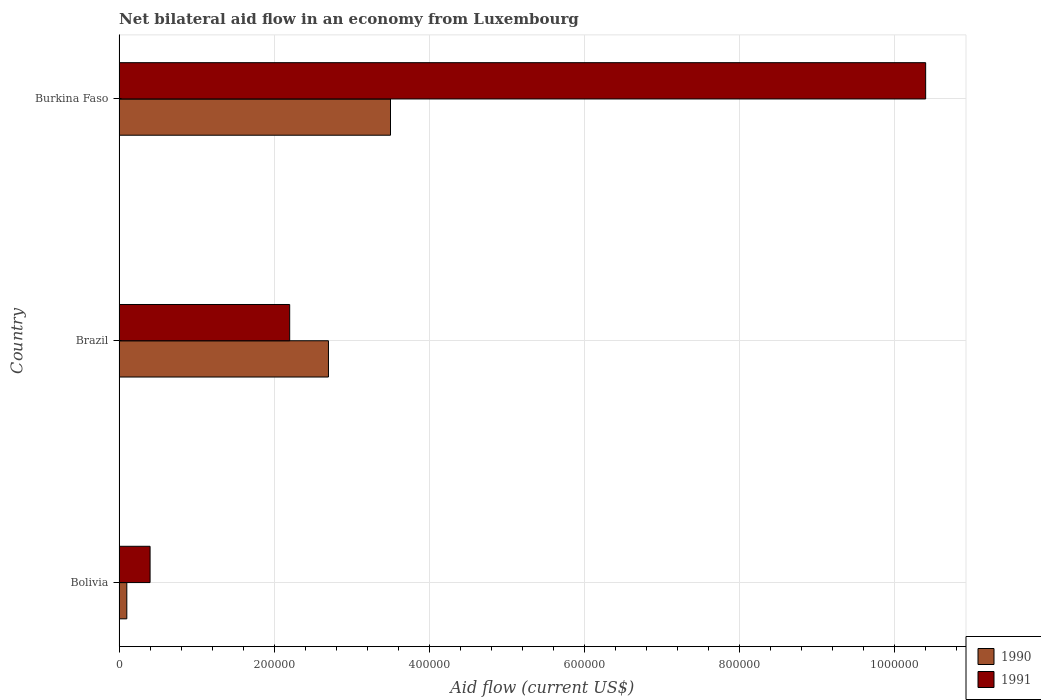How many groups of bars are there?
Offer a very short reply. 3. Are the number of bars on each tick of the Y-axis equal?
Give a very brief answer. Yes. How many bars are there on the 1st tick from the bottom?
Offer a very short reply. 2. What is the label of the 1st group of bars from the top?
Provide a short and direct response. Burkina Faso. In how many cases, is the number of bars for a given country not equal to the number of legend labels?
Your answer should be very brief. 0. Across all countries, what is the maximum net bilateral aid flow in 1991?
Keep it short and to the point. 1.04e+06. In which country was the net bilateral aid flow in 1991 maximum?
Give a very brief answer. Burkina Faso. In which country was the net bilateral aid flow in 1991 minimum?
Keep it short and to the point. Bolivia. What is the total net bilateral aid flow in 1990 in the graph?
Your answer should be very brief. 6.30e+05. What is the difference between the net bilateral aid flow in 1991 in Brazil and that in Burkina Faso?
Offer a very short reply. -8.20e+05. What is the difference between the net bilateral aid flow in 1991 in Burkina Faso and the net bilateral aid flow in 1990 in Bolivia?
Your answer should be compact. 1.03e+06. What is the average net bilateral aid flow in 1990 per country?
Ensure brevity in your answer.  2.10e+05. What is the difference between the net bilateral aid flow in 1991 and net bilateral aid flow in 1990 in Burkina Faso?
Ensure brevity in your answer.  6.90e+05. In how many countries, is the net bilateral aid flow in 1990 greater than 520000 US$?
Keep it short and to the point. 0. What is the ratio of the net bilateral aid flow in 1990 in Bolivia to that in Brazil?
Offer a terse response. 0.04. What is the difference between the highest and the second highest net bilateral aid flow in 1990?
Make the answer very short. 8.00e+04. What is the difference between the highest and the lowest net bilateral aid flow in 1991?
Provide a short and direct response. 1.00e+06. In how many countries, is the net bilateral aid flow in 1990 greater than the average net bilateral aid flow in 1990 taken over all countries?
Offer a very short reply. 2. Is the sum of the net bilateral aid flow in 1991 in Bolivia and Burkina Faso greater than the maximum net bilateral aid flow in 1990 across all countries?
Provide a succinct answer. Yes. What does the 2nd bar from the top in Bolivia represents?
Give a very brief answer. 1990. What does the 2nd bar from the bottom in Burkina Faso represents?
Provide a short and direct response. 1991. Does the graph contain grids?
Provide a succinct answer. Yes. Where does the legend appear in the graph?
Keep it short and to the point. Bottom right. How many legend labels are there?
Give a very brief answer. 2. What is the title of the graph?
Give a very brief answer. Net bilateral aid flow in an economy from Luxembourg. Does "1972" appear as one of the legend labels in the graph?
Offer a very short reply. No. What is the label or title of the X-axis?
Keep it short and to the point. Aid flow (current US$). What is the label or title of the Y-axis?
Your answer should be compact. Country. What is the Aid flow (current US$) of 1990 in Brazil?
Offer a terse response. 2.70e+05. What is the Aid flow (current US$) in 1991 in Burkina Faso?
Make the answer very short. 1.04e+06. Across all countries, what is the maximum Aid flow (current US$) of 1990?
Give a very brief answer. 3.50e+05. Across all countries, what is the maximum Aid flow (current US$) of 1991?
Your response must be concise. 1.04e+06. What is the total Aid flow (current US$) in 1990 in the graph?
Provide a succinct answer. 6.30e+05. What is the total Aid flow (current US$) in 1991 in the graph?
Provide a short and direct response. 1.30e+06. What is the difference between the Aid flow (current US$) in 1990 in Bolivia and that in Brazil?
Offer a very short reply. -2.60e+05. What is the difference between the Aid flow (current US$) of 1990 in Brazil and that in Burkina Faso?
Provide a short and direct response. -8.00e+04. What is the difference between the Aid flow (current US$) in 1991 in Brazil and that in Burkina Faso?
Provide a short and direct response. -8.20e+05. What is the difference between the Aid flow (current US$) in 1990 in Bolivia and the Aid flow (current US$) in 1991 in Brazil?
Offer a very short reply. -2.10e+05. What is the difference between the Aid flow (current US$) of 1990 in Bolivia and the Aid flow (current US$) of 1991 in Burkina Faso?
Ensure brevity in your answer.  -1.03e+06. What is the difference between the Aid flow (current US$) of 1990 in Brazil and the Aid flow (current US$) of 1991 in Burkina Faso?
Give a very brief answer. -7.70e+05. What is the average Aid flow (current US$) of 1990 per country?
Provide a succinct answer. 2.10e+05. What is the average Aid flow (current US$) in 1991 per country?
Provide a short and direct response. 4.33e+05. What is the difference between the Aid flow (current US$) of 1990 and Aid flow (current US$) of 1991 in Bolivia?
Your answer should be very brief. -3.00e+04. What is the difference between the Aid flow (current US$) of 1990 and Aid flow (current US$) of 1991 in Brazil?
Give a very brief answer. 5.00e+04. What is the difference between the Aid flow (current US$) of 1990 and Aid flow (current US$) of 1991 in Burkina Faso?
Offer a terse response. -6.90e+05. What is the ratio of the Aid flow (current US$) of 1990 in Bolivia to that in Brazil?
Make the answer very short. 0.04. What is the ratio of the Aid flow (current US$) of 1991 in Bolivia to that in Brazil?
Your response must be concise. 0.18. What is the ratio of the Aid flow (current US$) in 1990 in Bolivia to that in Burkina Faso?
Your answer should be compact. 0.03. What is the ratio of the Aid flow (current US$) of 1991 in Bolivia to that in Burkina Faso?
Make the answer very short. 0.04. What is the ratio of the Aid flow (current US$) of 1990 in Brazil to that in Burkina Faso?
Make the answer very short. 0.77. What is the ratio of the Aid flow (current US$) of 1991 in Brazil to that in Burkina Faso?
Your response must be concise. 0.21. What is the difference between the highest and the second highest Aid flow (current US$) of 1991?
Your response must be concise. 8.20e+05. What is the difference between the highest and the lowest Aid flow (current US$) of 1990?
Provide a short and direct response. 3.40e+05. What is the difference between the highest and the lowest Aid flow (current US$) of 1991?
Your answer should be very brief. 1.00e+06. 